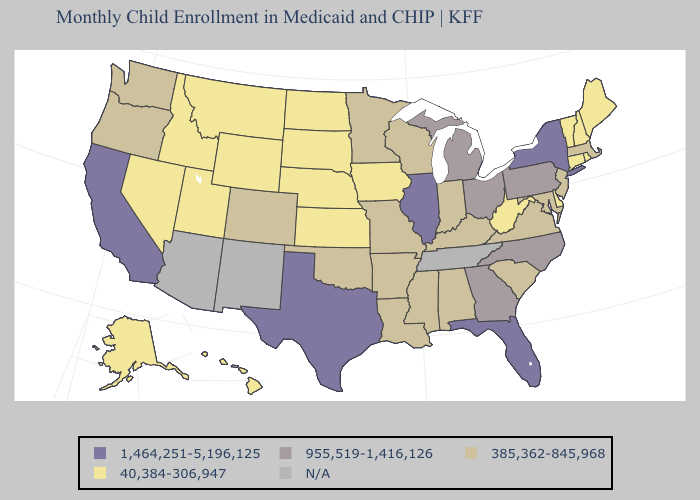What is the lowest value in the West?
Quick response, please. 40,384-306,947. Which states have the lowest value in the USA?
Concise answer only. Alaska, Connecticut, Delaware, Hawaii, Idaho, Iowa, Kansas, Maine, Montana, Nebraska, Nevada, New Hampshire, North Dakota, Rhode Island, South Dakota, Utah, Vermont, West Virginia, Wyoming. What is the lowest value in the Northeast?
Give a very brief answer. 40,384-306,947. What is the lowest value in the USA?
Be succinct. 40,384-306,947. Name the states that have a value in the range 1,464,251-5,196,125?
Write a very short answer. California, Florida, Illinois, New York, Texas. Name the states that have a value in the range N/A?
Answer briefly. Arizona, New Mexico, Tennessee. Among the states that border New York , does New Jersey have the highest value?
Give a very brief answer. No. What is the highest value in states that border Rhode Island?
Keep it brief. 385,362-845,968. What is the value of Connecticut?
Concise answer only. 40,384-306,947. Does the map have missing data?
Keep it brief. Yes. Among the states that border North Carolina , which have the highest value?
Quick response, please. Georgia. Does Rhode Island have the highest value in the Northeast?
Keep it brief. No. Among the states that border Vermont , does New York have the highest value?
Keep it brief. Yes. What is the lowest value in the South?
Quick response, please. 40,384-306,947. What is the value of Rhode Island?
Write a very short answer. 40,384-306,947. 